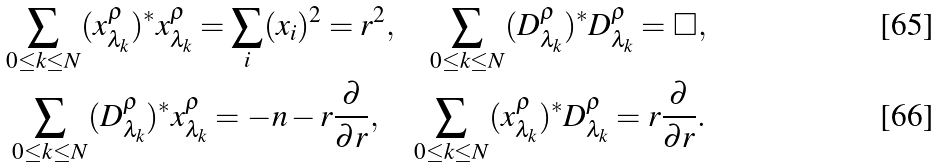Convert formula to latex. <formula><loc_0><loc_0><loc_500><loc_500>\sum _ { 0 \leq k \leq N } ( x _ { \lambda _ { k } } ^ { \rho } ) ^ { \ast } x _ { \lambda _ { k } } ^ { \rho } = \sum _ { i } ( x _ { i } ) ^ { 2 } = r ^ { 2 } , \quad \sum _ { 0 \leq k \leq N } ( D _ { \lambda _ { k } } ^ { \rho } ) ^ { \ast } D _ { \lambda _ { k } } ^ { \rho } = \square , \\ \sum _ { 0 \leq k \leq N } ( D _ { \lambda _ { k } } ^ { \rho } ) ^ { \ast } x _ { \lambda _ { k } } ^ { \rho } = - n - r \frac { \partial } { \partial r } , \quad \sum _ { 0 \leq k \leq N } ( x _ { \lambda _ { k } } ^ { \rho } ) ^ { \ast } D _ { \lambda _ { k } } ^ { \rho } = r \frac { \partial } { \partial r } .</formula> 